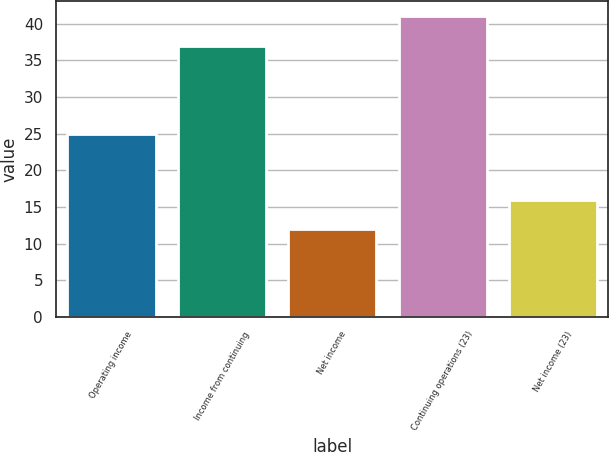Convert chart to OTSL. <chart><loc_0><loc_0><loc_500><loc_500><bar_chart><fcel>Operating income<fcel>Income from continuing<fcel>Net income<fcel>Continuing operations (23)<fcel>Net income (23)<nl><fcel>25<fcel>37<fcel>12<fcel>41<fcel>16<nl></chart> 